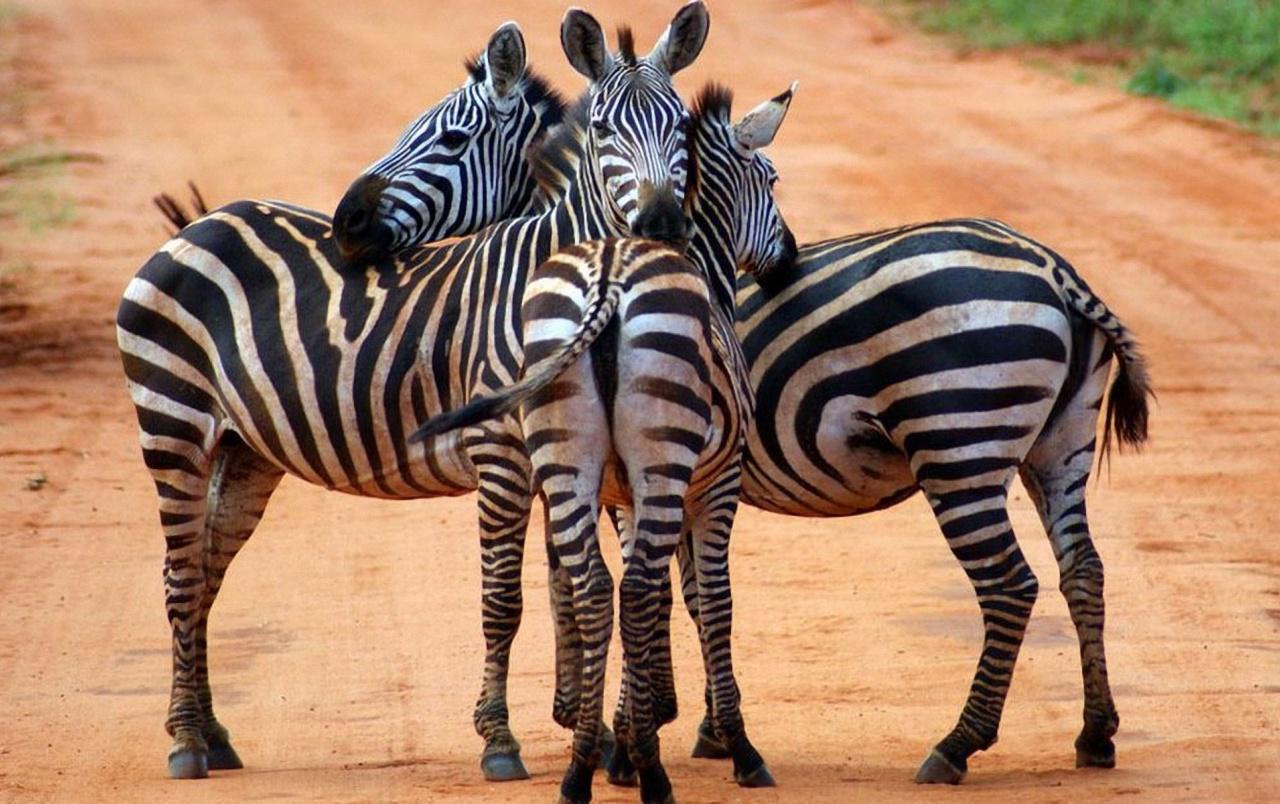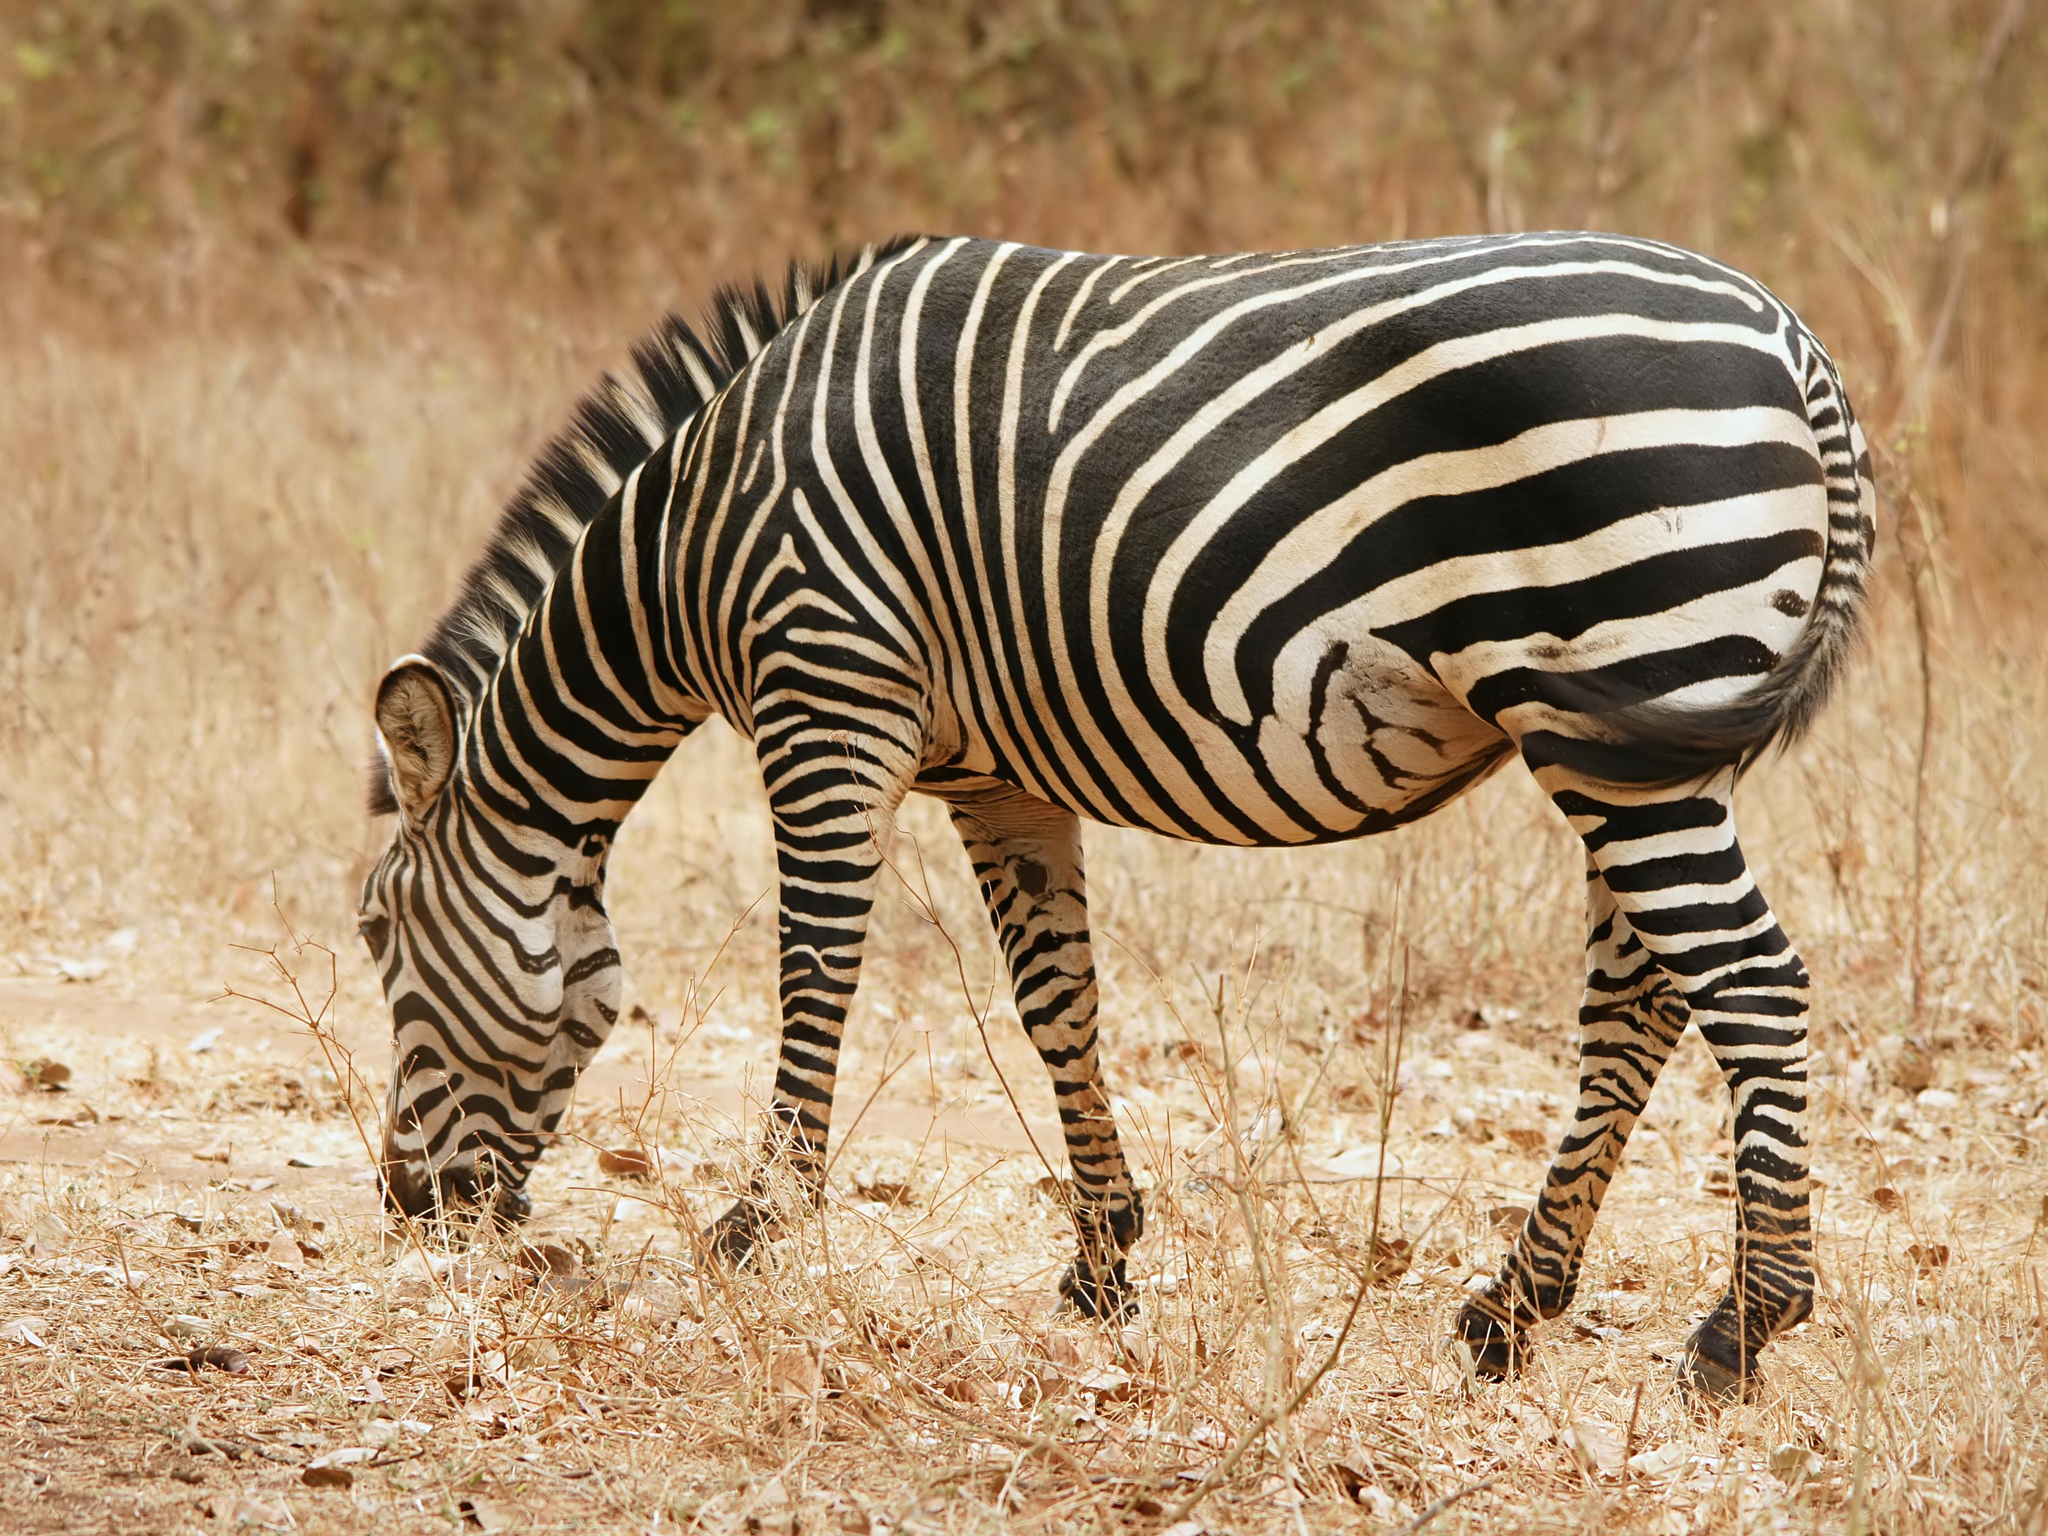The first image is the image on the left, the second image is the image on the right. For the images displayed, is the sentence "there are 6 zebras in the image pair" factually correct? Answer yes or no. No. The first image is the image on the left, the second image is the image on the right. Evaluate the accuracy of this statement regarding the images: "Each image contains exactly three foreground zebra that are close together in similar poses.". Is it true? Answer yes or no. No. 